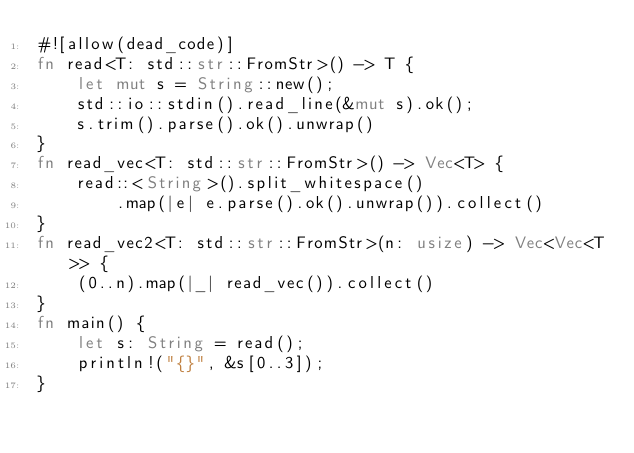<code> <loc_0><loc_0><loc_500><loc_500><_Rust_>#![allow(dead_code)]
fn read<T: std::str::FromStr>() -> T {
    let mut s = String::new();
    std::io::stdin().read_line(&mut s).ok();
    s.trim().parse().ok().unwrap()
}
fn read_vec<T: std::str::FromStr>() -> Vec<T> {
    read::<String>().split_whitespace()
        .map(|e| e.parse().ok().unwrap()).collect()
}
fn read_vec2<T: std::str::FromStr>(n: usize) -> Vec<Vec<T>> {
    (0..n).map(|_| read_vec()).collect()
}
fn main() {
    let s: String = read();
    println!("{}", &s[0..3]);
}</code> 